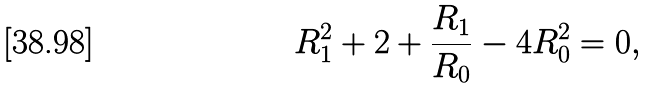<formula> <loc_0><loc_0><loc_500><loc_500>R _ { 1 } ^ { 2 } + 2 + \frac { R _ { 1 } } { R _ { 0 } } - 4 R _ { 0 } ^ { 2 } = 0 ,</formula> 